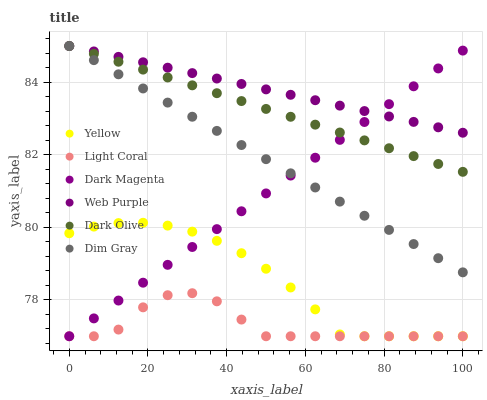Does Light Coral have the minimum area under the curve?
Answer yes or no. Yes. Does Web Purple have the maximum area under the curve?
Answer yes or no. Yes. Does Dark Magenta have the minimum area under the curve?
Answer yes or no. No. Does Dark Magenta have the maximum area under the curve?
Answer yes or no. No. Is Dark Magenta the smoothest?
Answer yes or no. Yes. Is Light Coral the roughest?
Answer yes or no. Yes. Is Dark Olive the smoothest?
Answer yes or no. No. Is Dark Olive the roughest?
Answer yes or no. No. Does Dark Magenta have the lowest value?
Answer yes or no. Yes. Does Dark Olive have the lowest value?
Answer yes or no. No. Does Web Purple have the highest value?
Answer yes or no. Yes. Does Dark Magenta have the highest value?
Answer yes or no. No. Is Yellow less than Dim Gray?
Answer yes or no. Yes. Is Web Purple greater than Yellow?
Answer yes or no. Yes. Does Dark Magenta intersect Light Coral?
Answer yes or no. Yes. Is Dark Magenta less than Light Coral?
Answer yes or no. No. Is Dark Magenta greater than Light Coral?
Answer yes or no. No. Does Yellow intersect Dim Gray?
Answer yes or no. No. 